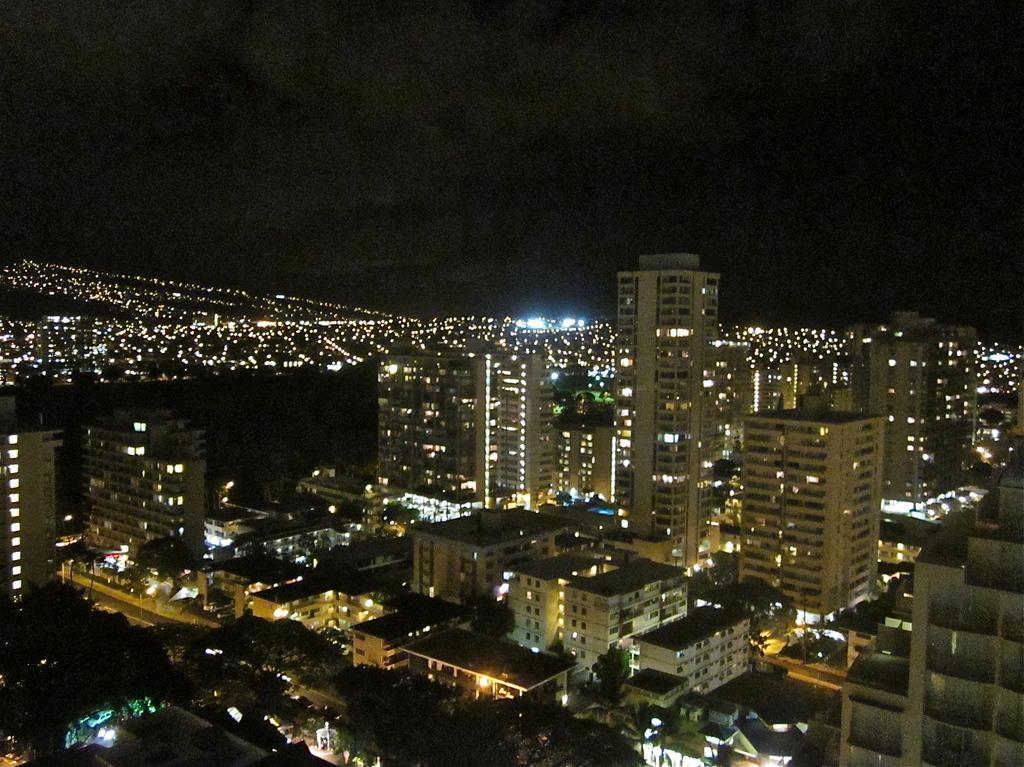How would you summarize this image in a sentence or two? In this image we can see the night view and there are some buildings and trees and at the top we can see the sky. 